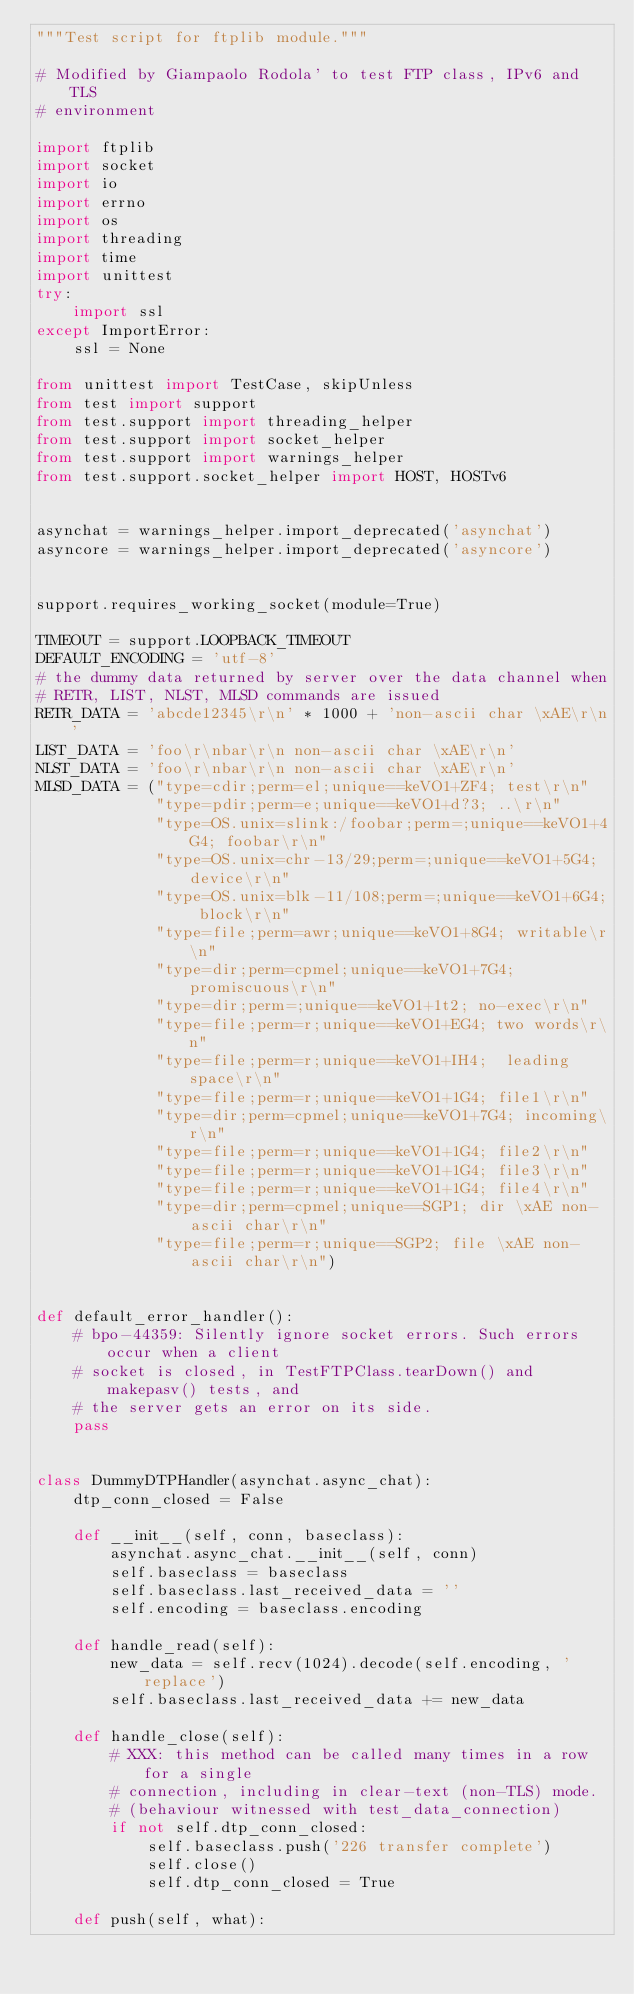Convert code to text. <code><loc_0><loc_0><loc_500><loc_500><_Python_>"""Test script for ftplib module."""

# Modified by Giampaolo Rodola' to test FTP class, IPv6 and TLS
# environment

import ftplib
import socket
import io
import errno
import os
import threading
import time
import unittest
try:
    import ssl
except ImportError:
    ssl = None

from unittest import TestCase, skipUnless
from test import support
from test.support import threading_helper
from test.support import socket_helper
from test.support import warnings_helper
from test.support.socket_helper import HOST, HOSTv6


asynchat = warnings_helper.import_deprecated('asynchat')
asyncore = warnings_helper.import_deprecated('asyncore')


support.requires_working_socket(module=True)

TIMEOUT = support.LOOPBACK_TIMEOUT
DEFAULT_ENCODING = 'utf-8'
# the dummy data returned by server over the data channel when
# RETR, LIST, NLST, MLSD commands are issued
RETR_DATA = 'abcde12345\r\n' * 1000 + 'non-ascii char \xAE\r\n'
LIST_DATA = 'foo\r\nbar\r\n non-ascii char \xAE\r\n'
NLST_DATA = 'foo\r\nbar\r\n non-ascii char \xAE\r\n'
MLSD_DATA = ("type=cdir;perm=el;unique==keVO1+ZF4; test\r\n"
             "type=pdir;perm=e;unique==keVO1+d?3; ..\r\n"
             "type=OS.unix=slink:/foobar;perm=;unique==keVO1+4G4; foobar\r\n"
             "type=OS.unix=chr-13/29;perm=;unique==keVO1+5G4; device\r\n"
             "type=OS.unix=blk-11/108;perm=;unique==keVO1+6G4; block\r\n"
             "type=file;perm=awr;unique==keVO1+8G4; writable\r\n"
             "type=dir;perm=cpmel;unique==keVO1+7G4; promiscuous\r\n"
             "type=dir;perm=;unique==keVO1+1t2; no-exec\r\n"
             "type=file;perm=r;unique==keVO1+EG4; two words\r\n"
             "type=file;perm=r;unique==keVO1+IH4;  leading space\r\n"
             "type=file;perm=r;unique==keVO1+1G4; file1\r\n"
             "type=dir;perm=cpmel;unique==keVO1+7G4; incoming\r\n"
             "type=file;perm=r;unique==keVO1+1G4; file2\r\n"
             "type=file;perm=r;unique==keVO1+1G4; file3\r\n"
             "type=file;perm=r;unique==keVO1+1G4; file4\r\n"
             "type=dir;perm=cpmel;unique==SGP1; dir \xAE non-ascii char\r\n"
             "type=file;perm=r;unique==SGP2; file \xAE non-ascii char\r\n")


def default_error_handler():
    # bpo-44359: Silently ignore socket errors. Such errors occur when a client
    # socket is closed, in TestFTPClass.tearDown() and makepasv() tests, and
    # the server gets an error on its side.
    pass


class DummyDTPHandler(asynchat.async_chat):
    dtp_conn_closed = False

    def __init__(self, conn, baseclass):
        asynchat.async_chat.__init__(self, conn)
        self.baseclass = baseclass
        self.baseclass.last_received_data = ''
        self.encoding = baseclass.encoding

    def handle_read(self):
        new_data = self.recv(1024).decode(self.encoding, 'replace')
        self.baseclass.last_received_data += new_data

    def handle_close(self):
        # XXX: this method can be called many times in a row for a single
        # connection, including in clear-text (non-TLS) mode.
        # (behaviour witnessed with test_data_connection)
        if not self.dtp_conn_closed:
            self.baseclass.push('226 transfer complete')
            self.close()
            self.dtp_conn_closed = True

    def push(self, what):</code> 